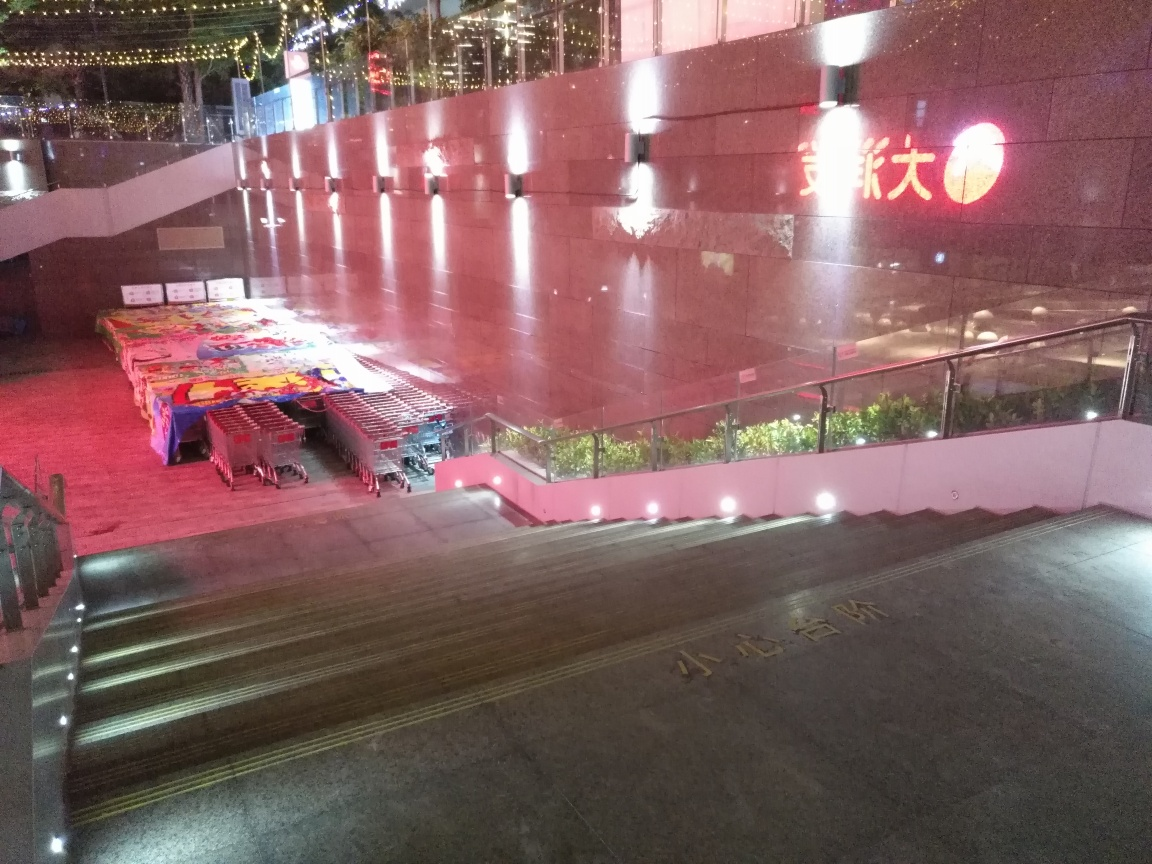What can we infer about the business or activity that takes place in this space during operational hours? Inferring from the carts and the canopy-covered tables, it seems like this area could be used for an outdoor market or as a vending area where various goods, perhaps food or local crafts, are sold during the day. The temporary nature of the setup suggests that the space is likely cleared out at the end of each business cycle. 